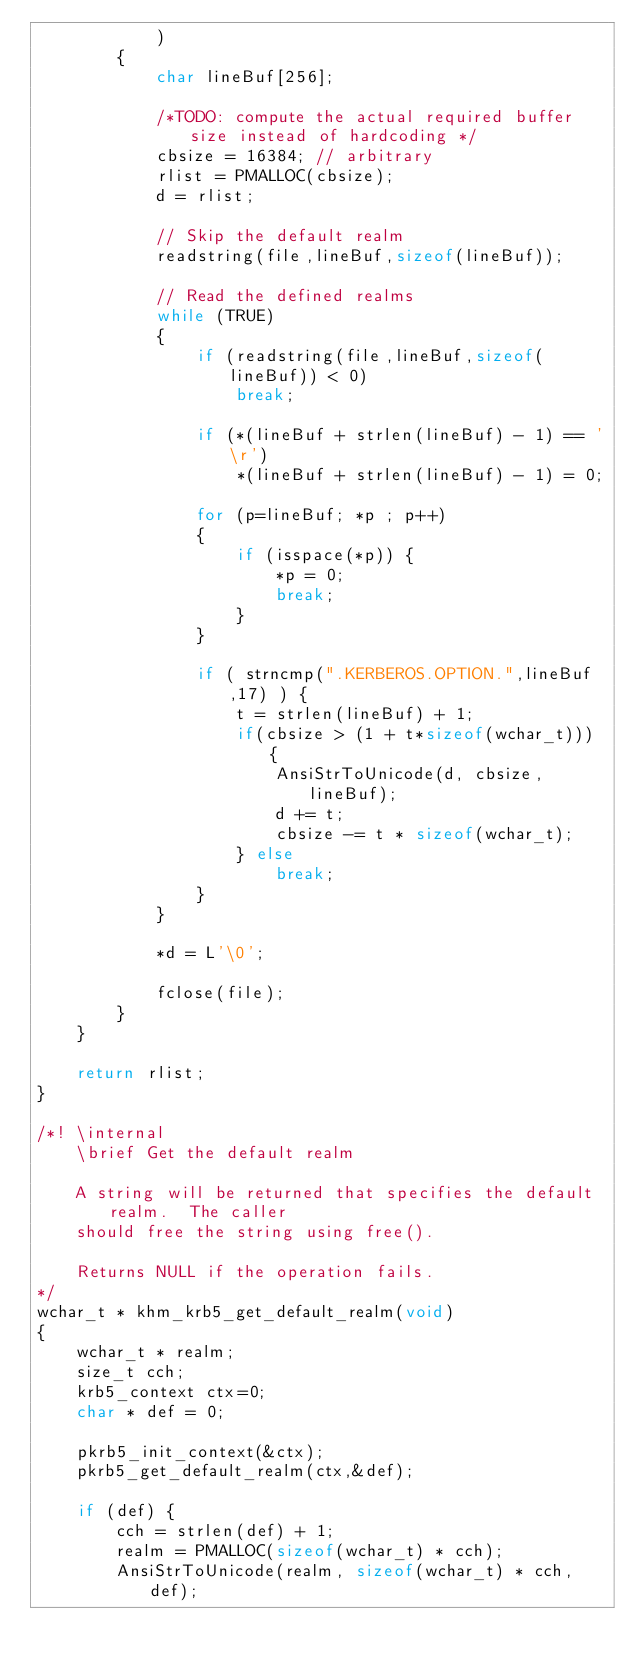<code> <loc_0><loc_0><loc_500><loc_500><_C_>            )
        {
            char lineBuf[256];

            /*TODO: compute the actual required buffer size instead of hardcoding */
            cbsize = 16384; // arbitrary
            rlist = PMALLOC(cbsize);
            d = rlist;

            // Skip the default realm
            readstring(file,lineBuf,sizeof(lineBuf));

            // Read the defined realms
            while (TRUE)
            {
                if (readstring(file,lineBuf,sizeof(lineBuf)) < 0)
                    break;

                if (*(lineBuf + strlen(lineBuf) - 1) == '\r')
                    *(lineBuf + strlen(lineBuf) - 1) = 0;

                for (p=lineBuf; *p ; p++)
                {
                    if (isspace(*p)) {
                        *p = 0;
                        break;
                    }
                }

                if ( strncmp(".KERBEROS.OPTION.",lineBuf,17) ) {
                    t = strlen(lineBuf) + 1;
                    if(cbsize > (1 + t*sizeof(wchar_t))) {
                        AnsiStrToUnicode(d, cbsize, lineBuf);
                        d += t;
                        cbsize -= t * sizeof(wchar_t);
                    } else
                        break;
                }
            }

            *d = L'\0';

            fclose(file);
        }
    }

    return rlist;
}

/*! \internal
    \brief Get the default realm

    A string will be returned that specifies the default realm.  The caller
    should free the string using free().

    Returns NULL if the operation fails.
*/
wchar_t * khm_krb5_get_default_realm(void)
{
    wchar_t * realm;
    size_t cch;
    krb5_context ctx=0;
    char * def = 0;

    pkrb5_init_context(&ctx);
    pkrb5_get_default_realm(ctx,&def);

    if (def) {
        cch = strlen(def) + 1;
        realm = PMALLOC(sizeof(wchar_t) * cch);
        AnsiStrToUnicode(realm, sizeof(wchar_t) * cch, def);</code> 